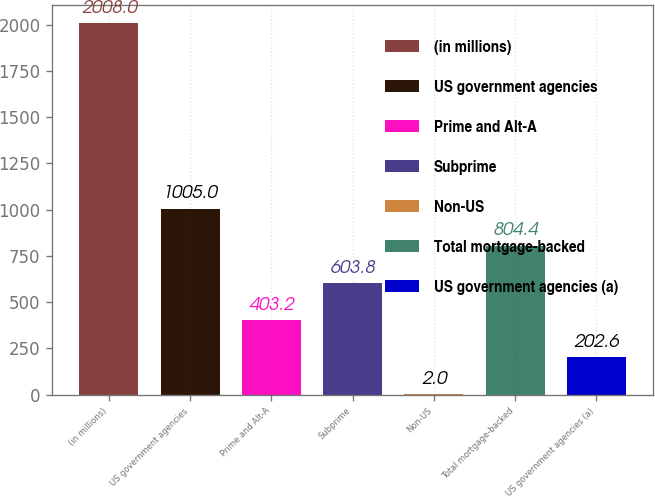<chart> <loc_0><loc_0><loc_500><loc_500><bar_chart><fcel>(in millions)<fcel>US government agencies<fcel>Prime and Alt-A<fcel>Subprime<fcel>Non-US<fcel>Total mortgage-backed<fcel>US government agencies (a)<nl><fcel>2008<fcel>1005<fcel>403.2<fcel>603.8<fcel>2<fcel>804.4<fcel>202.6<nl></chart> 